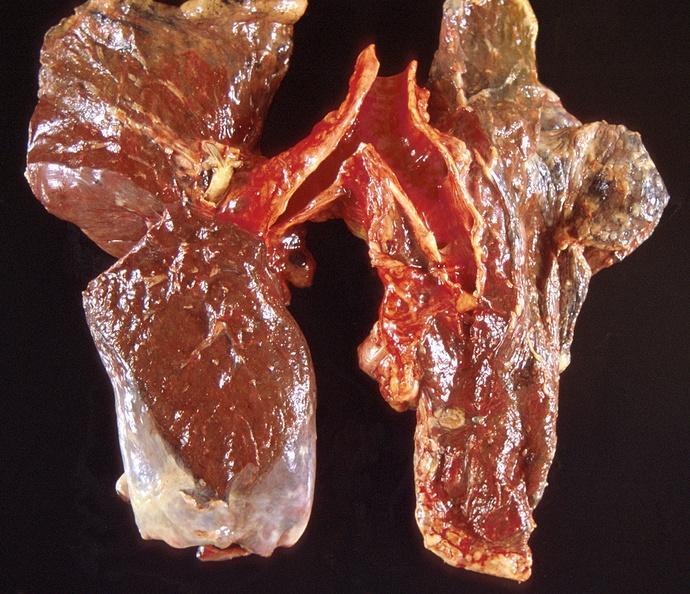what does this image show?
Answer the question using a single word or phrase. Lung carcinoma 